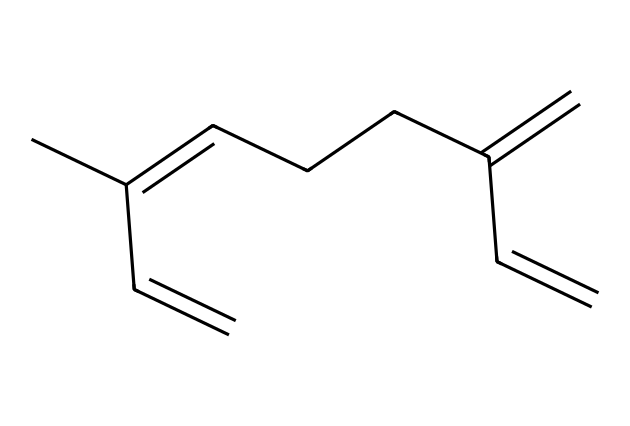How many carbon atoms are in myrcene? Counting the carbons in the SMILES representation, we see "CC" at the beginning, followed by multiple instances of "C", totaling to 10 carbon atoms in the structure overall.
Answer: 10 What is the degree of unsaturation in myrcene? The degree of unsaturation can be calculated by the formula: (2C + 2 + N - H - X)/2. Here, C = 10, H = 16, leading to (2(10) + 2 - 16)/2 = 3. This indicates there are three pi bonds (double bonds).
Answer: 3 How many double bonds are present in myrcene? From the SMILES representation, we identify three occurrences of "=" which denote double bonds. Therefore, there are three double bonds in the molecule.
Answer: 3 What functional group is primarily present in myrcene? Analyzing the structure, the double bonds suggest that myrcene contains alkenes as its functional group since it has multiple carbon-carbon double bonds.
Answer: alkene Is myrcene a cyclic or acyclic compound? The SMILES structure shows a linear arrangement of carbon atoms without any cyclical structures indicating it is an acyclic compound.
Answer: acyclic What type of terpene is myrcene classified as? Myrcene falls under the category of monoterpenes because it is formed from two isoprene units, which gives it a C10H16 structure.
Answer: monoterpene 